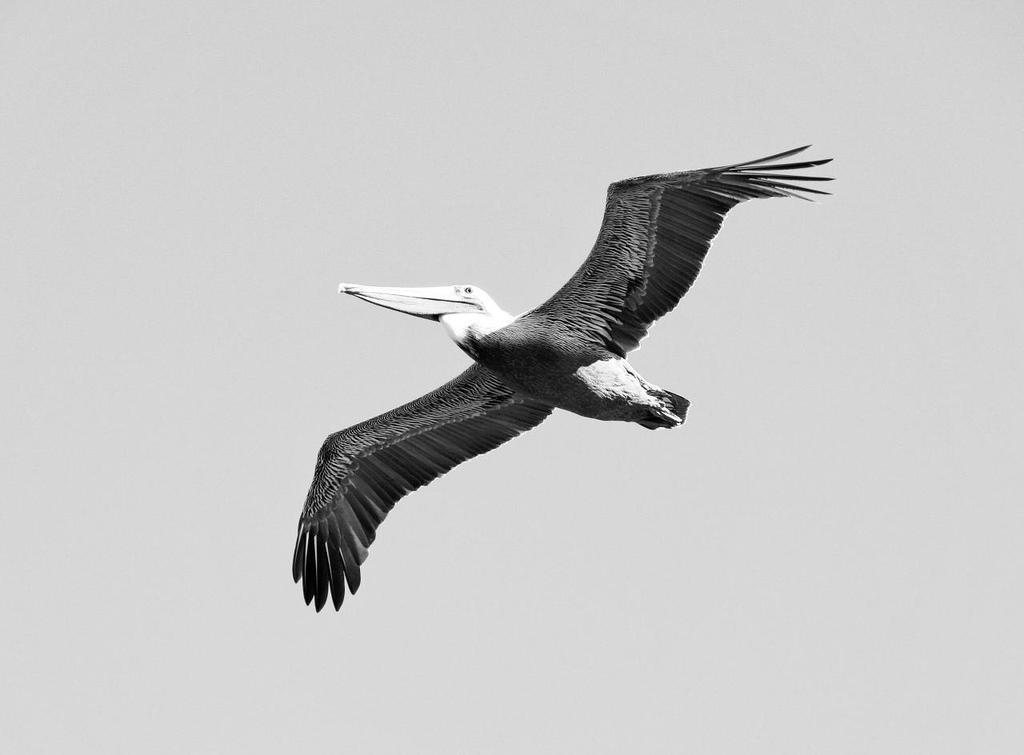Describe this image in one or two sentences. In the picture we can see the bird flying in the air with a long beak. 